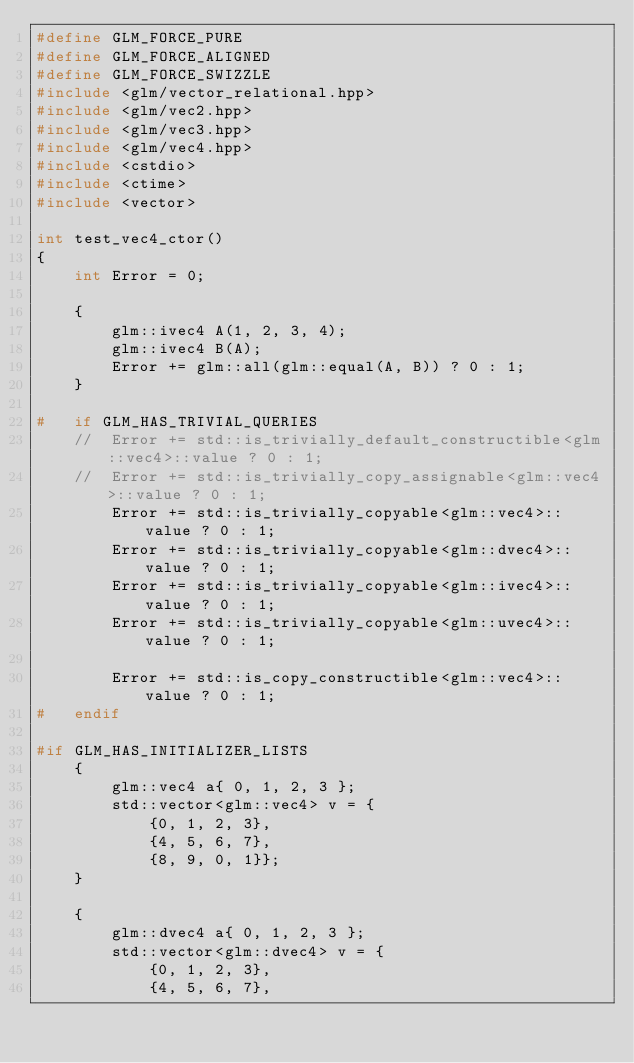Convert code to text. <code><loc_0><loc_0><loc_500><loc_500><_C++_>#define GLM_FORCE_PURE
#define GLM_FORCE_ALIGNED
#define GLM_FORCE_SWIZZLE
#include <glm/vector_relational.hpp>
#include <glm/vec2.hpp>
#include <glm/vec3.hpp>
#include <glm/vec4.hpp>
#include <cstdio>
#include <ctime>
#include <vector>

int test_vec4_ctor()
{
	int Error = 0;

	{
		glm::ivec4 A(1, 2, 3, 4);
		glm::ivec4 B(A);
		Error += glm::all(glm::equal(A, B)) ? 0 : 1;
	}

#	if GLM_HAS_TRIVIAL_QUERIES
	//	Error += std::is_trivially_default_constructible<glm::vec4>::value ? 0 : 1;
	//	Error += std::is_trivially_copy_assignable<glm::vec4>::value ? 0 : 1;
		Error += std::is_trivially_copyable<glm::vec4>::value ? 0 : 1;
		Error += std::is_trivially_copyable<glm::dvec4>::value ? 0 : 1;
		Error += std::is_trivially_copyable<glm::ivec4>::value ? 0 : 1;
		Error += std::is_trivially_copyable<glm::uvec4>::value ? 0 : 1;

		Error += std::is_copy_constructible<glm::vec4>::value ? 0 : 1;
#	endif

#if GLM_HAS_INITIALIZER_LISTS
	{
		glm::vec4 a{ 0, 1, 2, 3 };
		std::vector<glm::vec4> v = {
			{0, 1, 2, 3},
			{4, 5, 6, 7},
			{8, 9, 0, 1}};
	}

	{
		glm::dvec4 a{ 0, 1, 2, 3 };
		std::vector<glm::dvec4> v = {
			{0, 1, 2, 3},
			{4, 5, 6, 7},</code> 